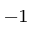Convert formula to latex. <formula><loc_0><loc_0><loc_500><loc_500>^ { - 1 }</formula> 